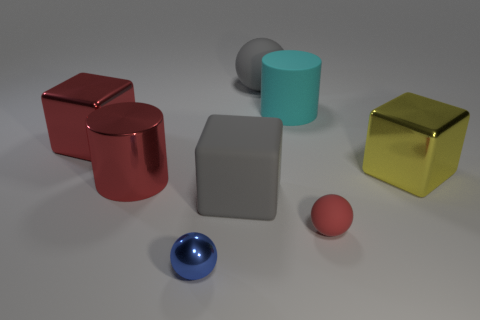Subtract all rubber spheres. How many spheres are left? 1 Subtract all yellow blocks. How many blocks are left? 2 Add 1 shiny things. How many objects exist? 9 Subtract all cylinders. How many objects are left? 6 Subtract 2 balls. How many balls are left? 1 Subtract all green cubes. Subtract all purple spheres. How many cubes are left? 3 Subtract all big brown shiny cubes. Subtract all red metal cubes. How many objects are left? 7 Add 2 large shiny cylinders. How many large shiny cylinders are left? 3 Add 3 big rubber objects. How many big rubber objects exist? 6 Subtract 1 gray blocks. How many objects are left? 7 